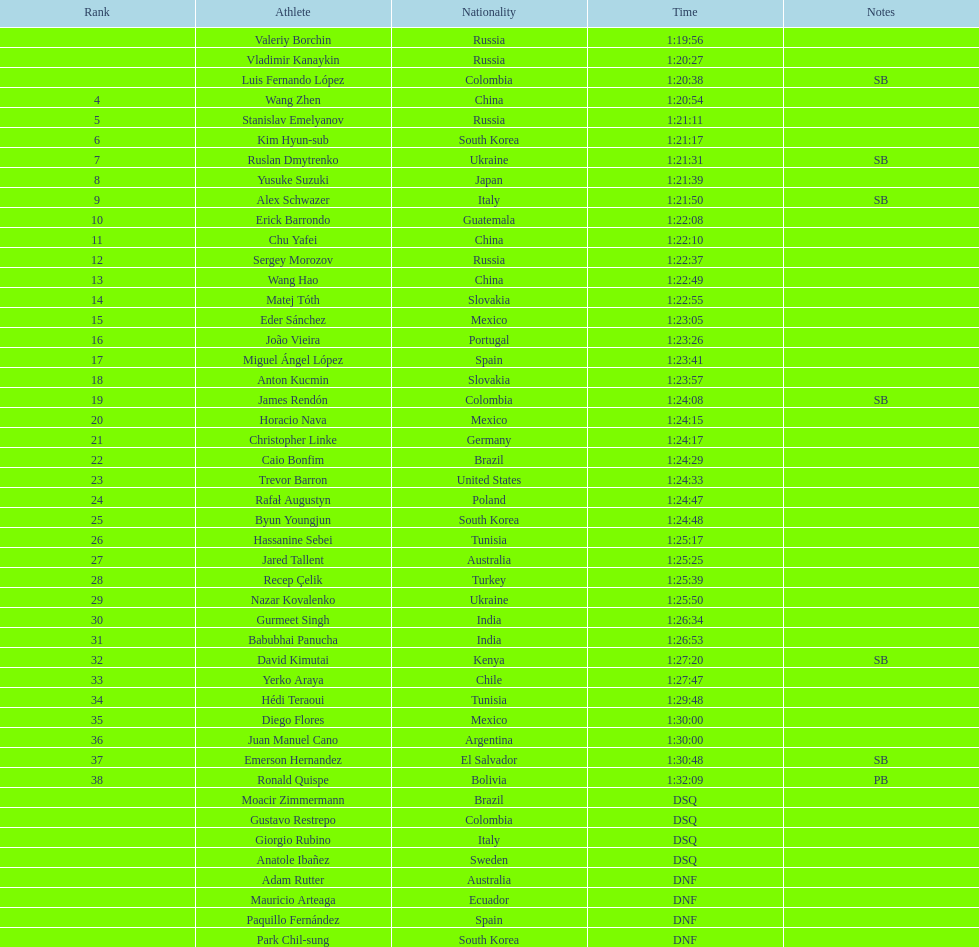What is the aggregate sum of athletes listed in the rankings chart, involving those identified as dsq & dnf? 46. 